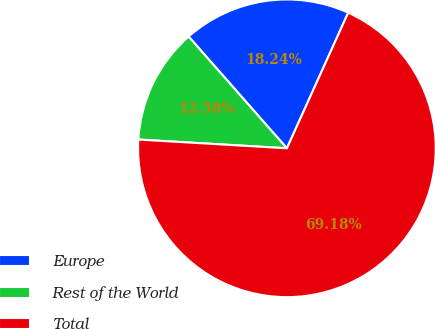Convert chart to OTSL. <chart><loc_0><loc_0><loc_500><loc_500><pie_chart><fcel>Europe<fcel>Rest of the World<fcel>Total<nl><fcel>18.24%<fcel>12.58%<fcel>69.18%<nl></chart> 